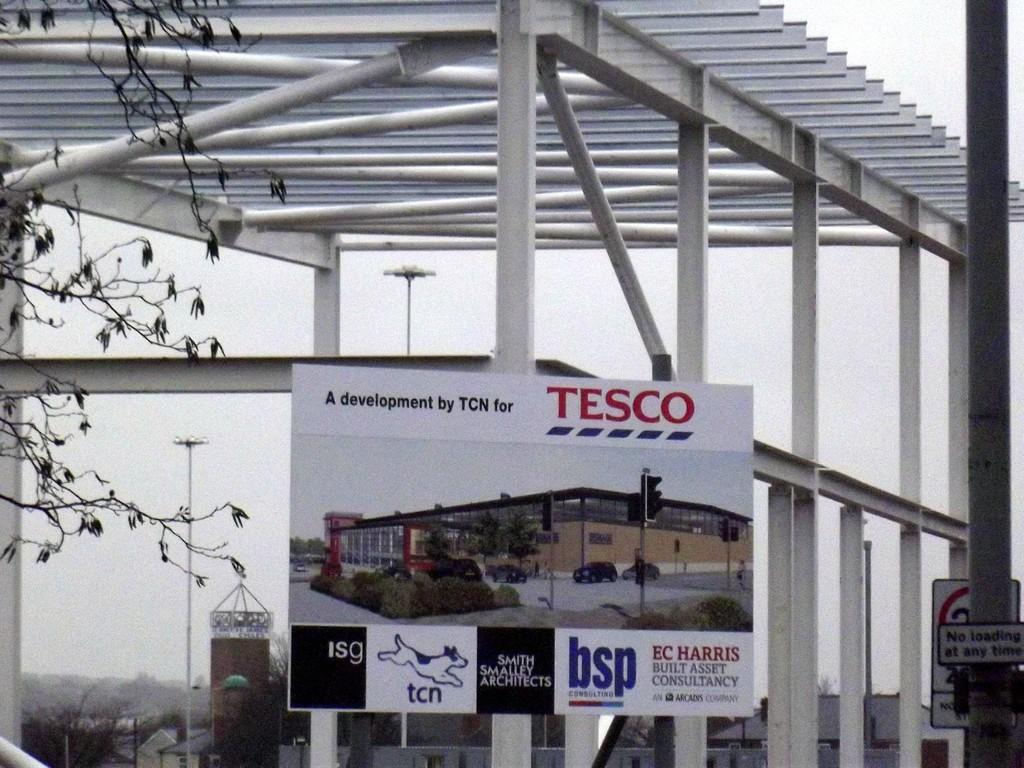What is the main subject in the center of the image? There is a poster in the center of the image. What can be seen on the right side of the image? There is a pole on the right side of the image. What type of vegetation is visible in the bottom left side of the image? There are trees in the bottom left side of the image. What type of root is visible in the image? There is no root visible in the image. 